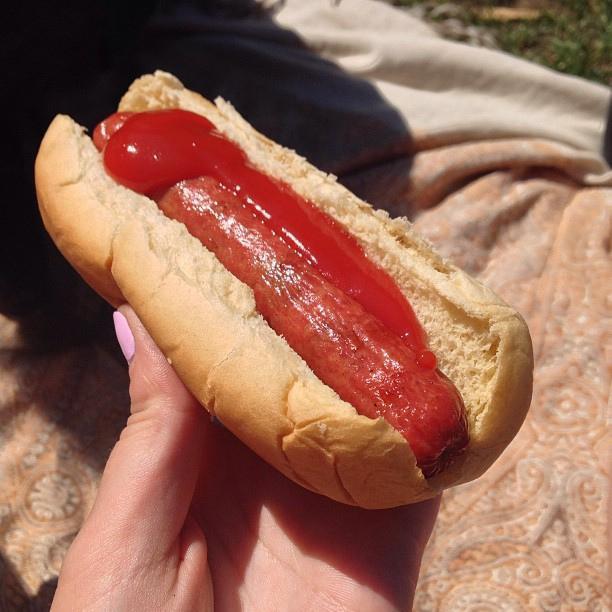How many people are there?
Give a very brief answer. 1. How many dogs are there?
Give a very brief answer. 0. 